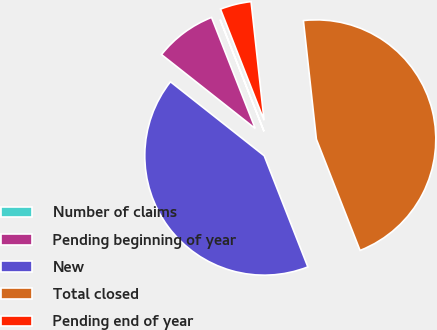Convert chart to OTSL. <chart><loc_0><loc_0><loc_500><loc_500><pie_chart><fcel>Number of claims<fcel>Pending beginning of year<fcel>New<fcel>Total closed<fcel>Pending end of year<nl><fcel>0.02%<fcel>8.4%<fcel>41.59%<fcel>45.78%<fcel>4.21%<nl></chart> 